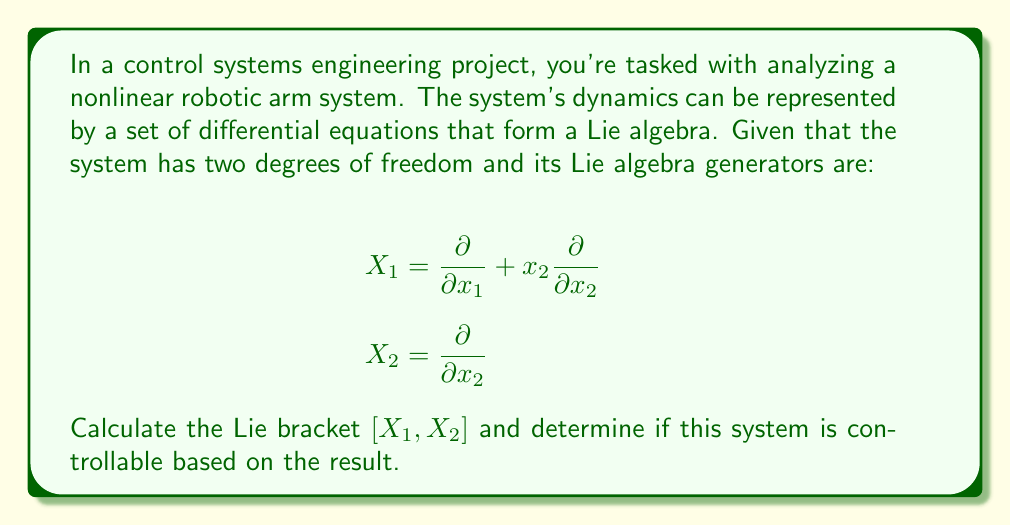Show me your answer to this math problem. To solve this problem, we'll follow these steps:

1) First, let's recall the definition of the Lie bracket for vector fields. For two vector fields $X$ and $Y$, their Lie bracket $[X,Y]$ is defined as:

   $$[X,Y] = XY - YX$$

2) In our case, we need to calculate $[X_1, X_2]$. Let's apply $X_1$ to $X_2$ and vice versa:

   $X_1X_2 = X_1(\frac{\partial}{\partial x_2}) = \frac{\partial}{\partial x_2}(\frac{\partial}{\partial x_1} + x_2\frac{\partial}{\partial x_2}) = \frac{\partial}{\partial x_2}$

   $X_2X_1 = X_2(\frac{\partial}{\partial x_1} + x_2\frac{\partial}{\partial x_2}) = \frac{\partial}{\partial x_2}(x_2\frac{\partial}{\partial x_2}) = \frac{\partial}{\partial x_2}$

3) Now, we can calculate the Lie bracket:

   $$[X_1, X_2] = X_1X_2 - X_2X_1 = \frac{\partial}{\partial x_2} - \frac{\partial}{\partial x_2} = 0$$

4) To determine controllability, we use the Lie algebra rank condition. A system is controllable if the Lie algebra generated by its vector fields spans the entire state space at every point.

5) In this case, we have:
   - $X_1 = \frac{\partial}{\partial x_1} + x_2\frac{\partial}{\partial x_2}$
   - $X_2 = \frac{\partial}{\partial x_2}$
   - $[X_1, X_2] = 0$

   The span of these vector fields is indeed the entire 2-dimensional state space at every point, as $X_1$ and $X_2$ are linearly independent.

Therefore, despite $[X_1, X_2] = 0$, the system is still controllable because $X_1$ and $X_2$ span the entire state space.
Answer: The Lie bracket $[X_1, X_2] = 0$. The system is controllable because the vector fields $X_1$ and $X_2$ span the entire 2-dimensional state space at every point. 